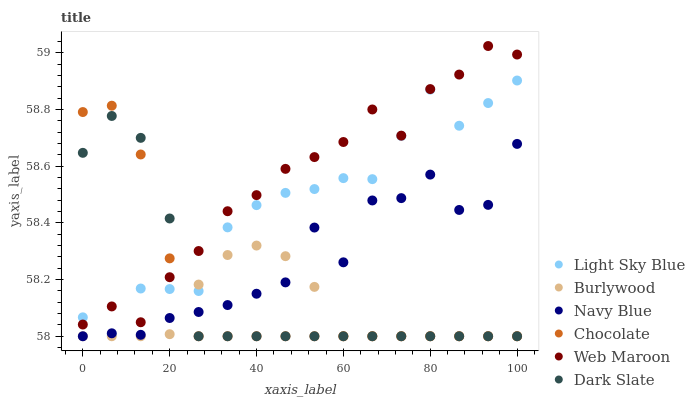Does Burlywood have the minimum area under the curve?
Answer yes or no. Yes. Does Web Maroon have the maximum area under the curve?
Answer yes or no. Yes. Does Navy Blue have the minimum area under the curve?
Answer yes or no. No. Does Navy Blue have the maximum area under the curve?
Answer yes or no. No. Is Burlywood the smoothest?
Answer yes or no. Yes. Is Navy Blue the roughest?
Answer yes or no. Yes. Is Web Maroon the smoothest?
Answer yes or no. No. Is Web Maroon the roughest?
Answer yes or no. No. Does Burlywood have the lowest value?
Answer yes or no. Yes. Does Web Maroon have the lowest value?
Answer yes or no. No. Does Web Maroon have the highest value?
Answer yes or no. Yes. Does Navy Blue have the highest value?
Answer yes or no. No. Is Navy Blue less than Web Maroon?
Answer yes or no. Yes. Is Web Maroon greater than Navy Blue?
Answer yes or no. Yes. Does Light Sky Blue intersect Navy Blue?
Answer yes or no. Yes. Is Light Sky Blue less than Navy Blue?
Answer yes or no. No. Is Light Sky Blue greater than Navy Blue?
Answer yes or no. No. Does Navy Blue intersect Web Maroon?
Answer yes or no. No. 